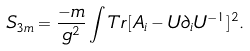<formula> <loc_0><loc_0><loc_500><loc_500>S _ { 3 m } = \frac { - m } { g ^ { 2 } } \int T r [ A _ { i } - U \partial _ { i } U ^ { - 1 } ] ^ { 2 } .</formula> 